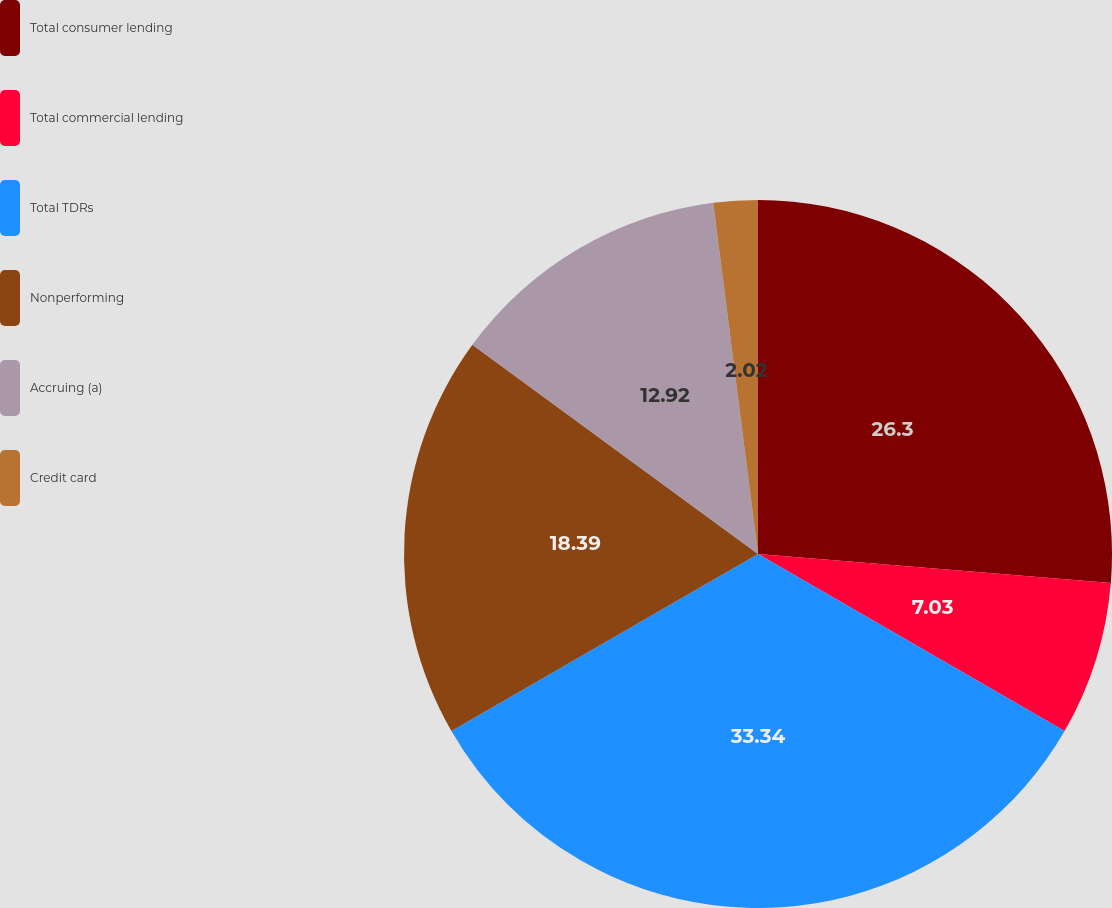<chart> <loc_0><loc_0><loc_500><loc_500><pie_chart><fcel>Total consumer lending<fcel>Total commercial lending<fcel>Total TDRs<fcel>Nonperforming<fcel>Accruing (a)<fcel>Credit card<nl><fcel>26.3%<fcel>7.03%<fcel>33.33%<fcel>18.39%<fcel>12.92%<fcel>2.02%<nl></chart> 